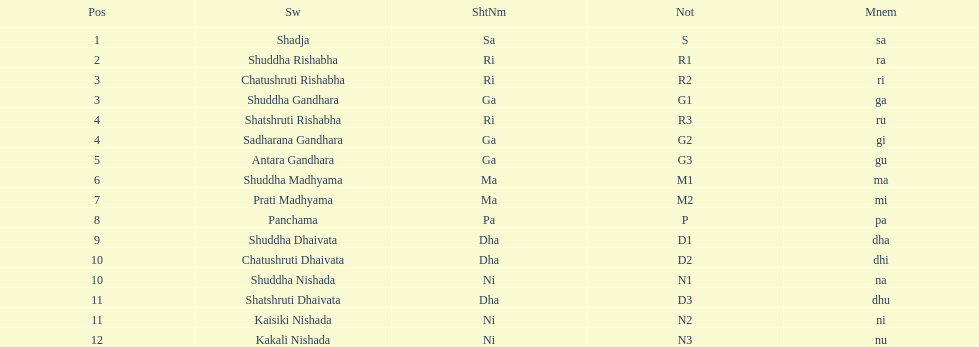What is the total number of positions listed? 16. 